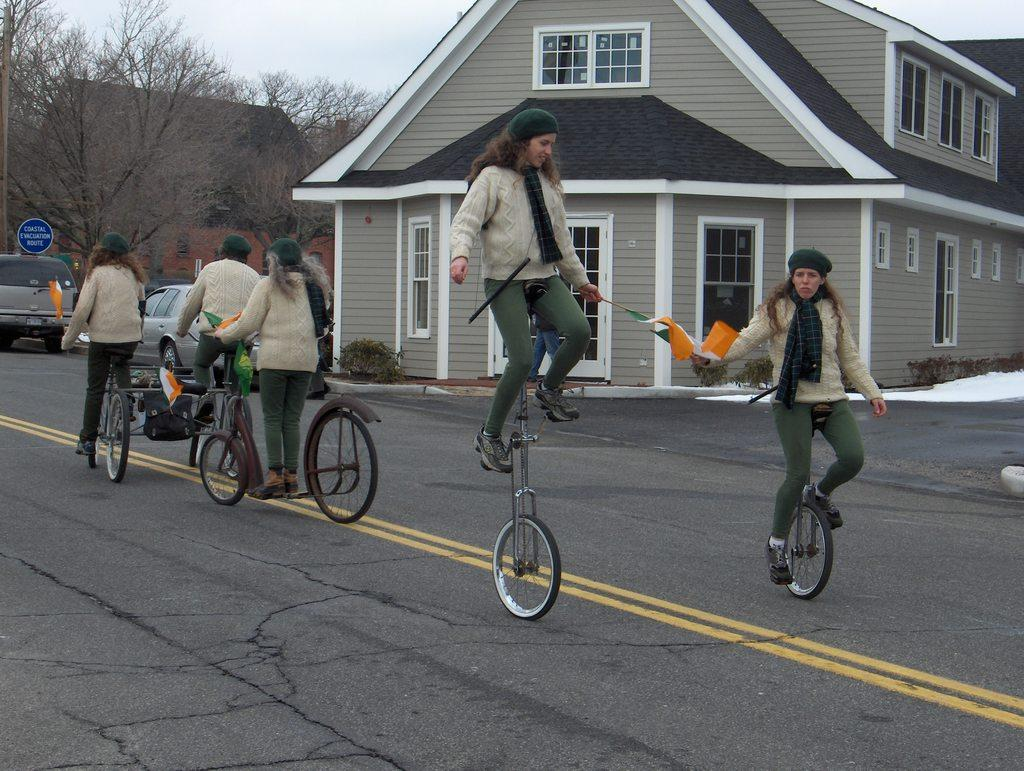What are the people in the image doing? The people in the image are riding bicycles. What else can be seen in the image besides the people on bicycles? There are flags, cars, houses, trees, and the sky visible in the image. What type of glass is being used by the people riding bicycles in the image? There is no glass present in the image; it features people riding bicycles, flags, cars, houses, trees, and the sky. 